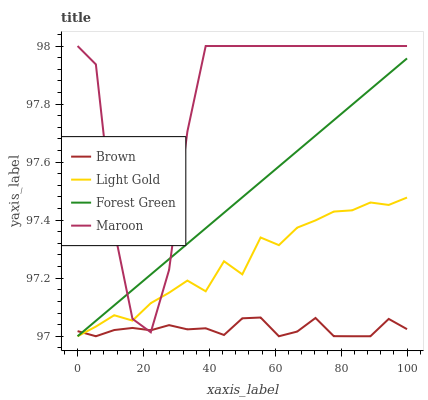Does Brown have the minimum area under the curve?
Answer yes or no. Yes. Does Maroon have the maximum area under the curve?
Answer yes or no. Yes. Does Forest Green have the minimum area under the curve?
Answer yes or no. No. Does Forest Green have the maximum area under the curve?
Answer yes or no. No. Is Forest Green the smoothest?
Answer yes or no. Yes. Is Maroon the roughest?
Answer yes or no. Yes. Is Light Gold the smoothest?
Answer yes or no. No. Is Light Gold the roughest?
Answer yes or no. No. Does Maroon have the lowest value?
Answer yes or no. No. Does Forest Green have the highest value?
Answer yes or no. No. 